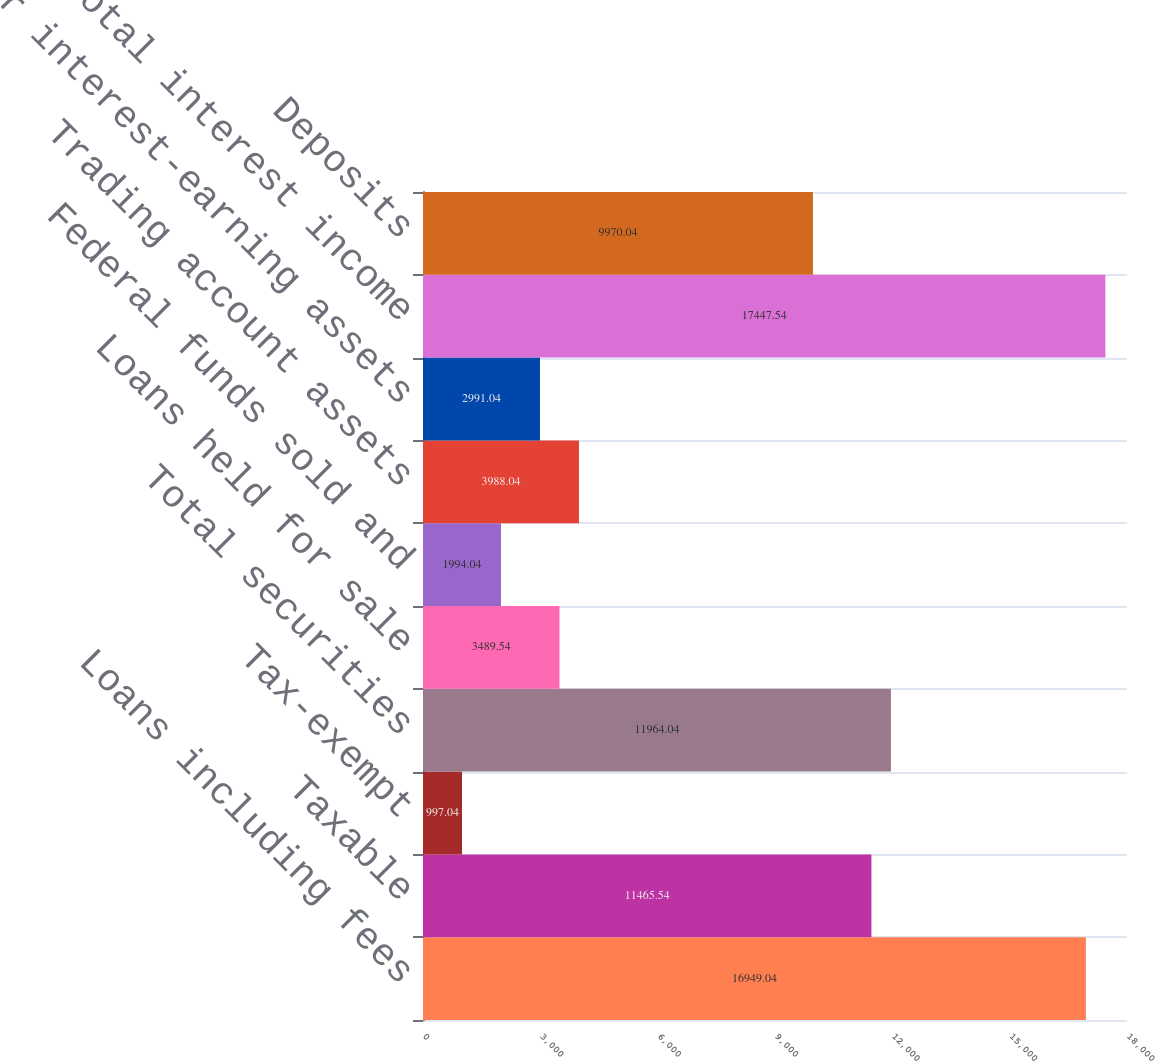Convert chart. <chart><loc_0><loc_0><loc_500><loc_500><bar_chart><fcel>Loans including fees<fcel>Taxable<fcel>Tax-exempt<fcel>Total securities<fcel>Loans held for sale<fcel>Federal funds sold and<fcel>Trading account assets<fcel>Other interest-earning assets<fcel>Total interest income<fcel>Deposits<nl><fcel>16949<fcel>11465.5<fcel>997.04<fcel>11964<fcel>3489.54<fcel>1994.04<fcel>3988.04<fcel>2991.04<fcel>17447.5<fcel>9970.04<nl></chart> 